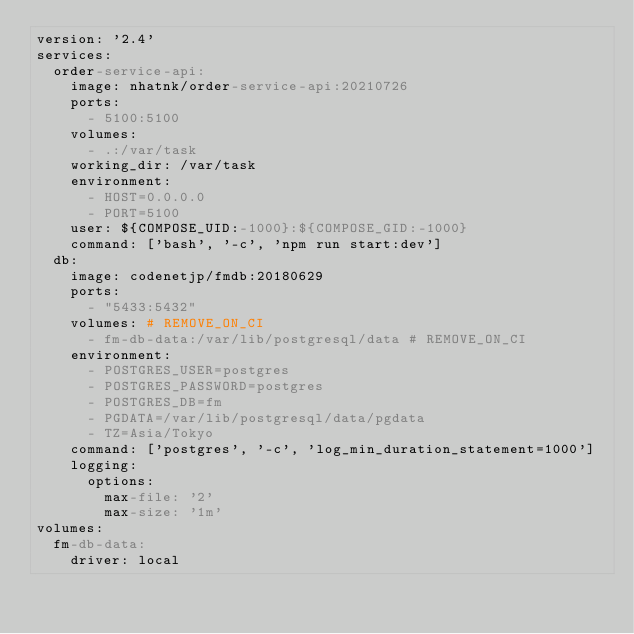<code> <loc_0><loc_0><loc_500><loc_500><_YAML_>version: '2.4'
services:
  order-service-api:
    image: nhatnk/order-service-api:20210726
    ports:
      - 5100:5100
    volumes:
      - .:/var/task
    working_dir: /var/task
    environment:
      - HOST=0.0.0.0
      - PORT=5100
    user: ${COMPOSE_UID:-1000}:${COMPOSE_GID:-1000}
    command: ['bash', '-c', 'npm run start:dev']
  db:
    image: codenetjp/fmdb:20180629
    ports:
      - "5433:5432"
    volumes: # REMOVE_ON_CI
      - fm-db-data:/var/lib/postgresql/data # REMOVE_ON_CI
    environment:
      - POSTGRES_USER=postgres
      - POSTGRES_PASSWORD=postgres
      - POSTGRES_DB=fm
      - PGDATA=/var/lib/postgresql/data/pgdata
      - TZ=Asia/Tokyo
    command: ['postgres', '-c', 'log_min_duration_statement=1000']
    logging:
      options:
        max-file: '2'
        max-size: '1m'
volumes:
  fm-db-data:
    driver: local</code> 